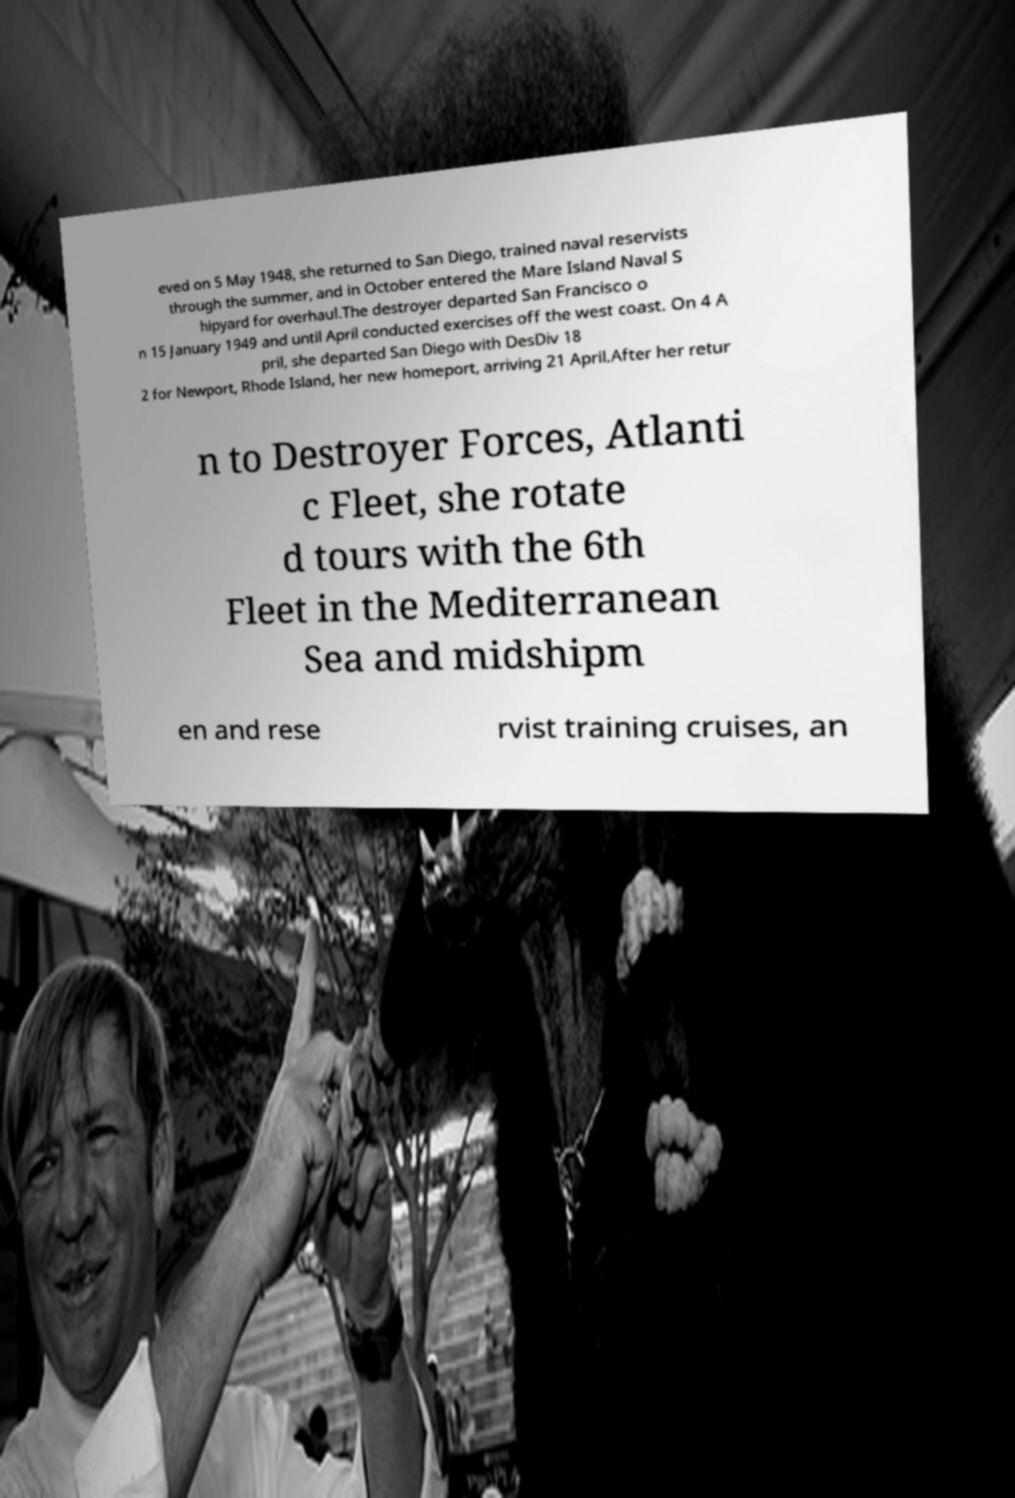Can you read and provide the text displayed in the image?This photo seems to have some interesting text. Can you extract and type it out for me? eved on 5 May 1948, she returned to San Diego, trained naval reservists through the summer, and in October entered the Mare Island Naval S hipyard for overhaul.The destroyer departed San Francisco o n 15 January 1949 and until April conducted exercises off the west coast. On 4 A pril, she departed San Diego with DesDiv 18 2 for Newport, Rhode Island, her new homeport, arriving 21 April.After her retur n to Destroyer Forces, Atlanti c Fleet, she rotate d tours with the 6th Fleet in the Mediterranean Sea and midshipm en and rese rvist training cruises, an 